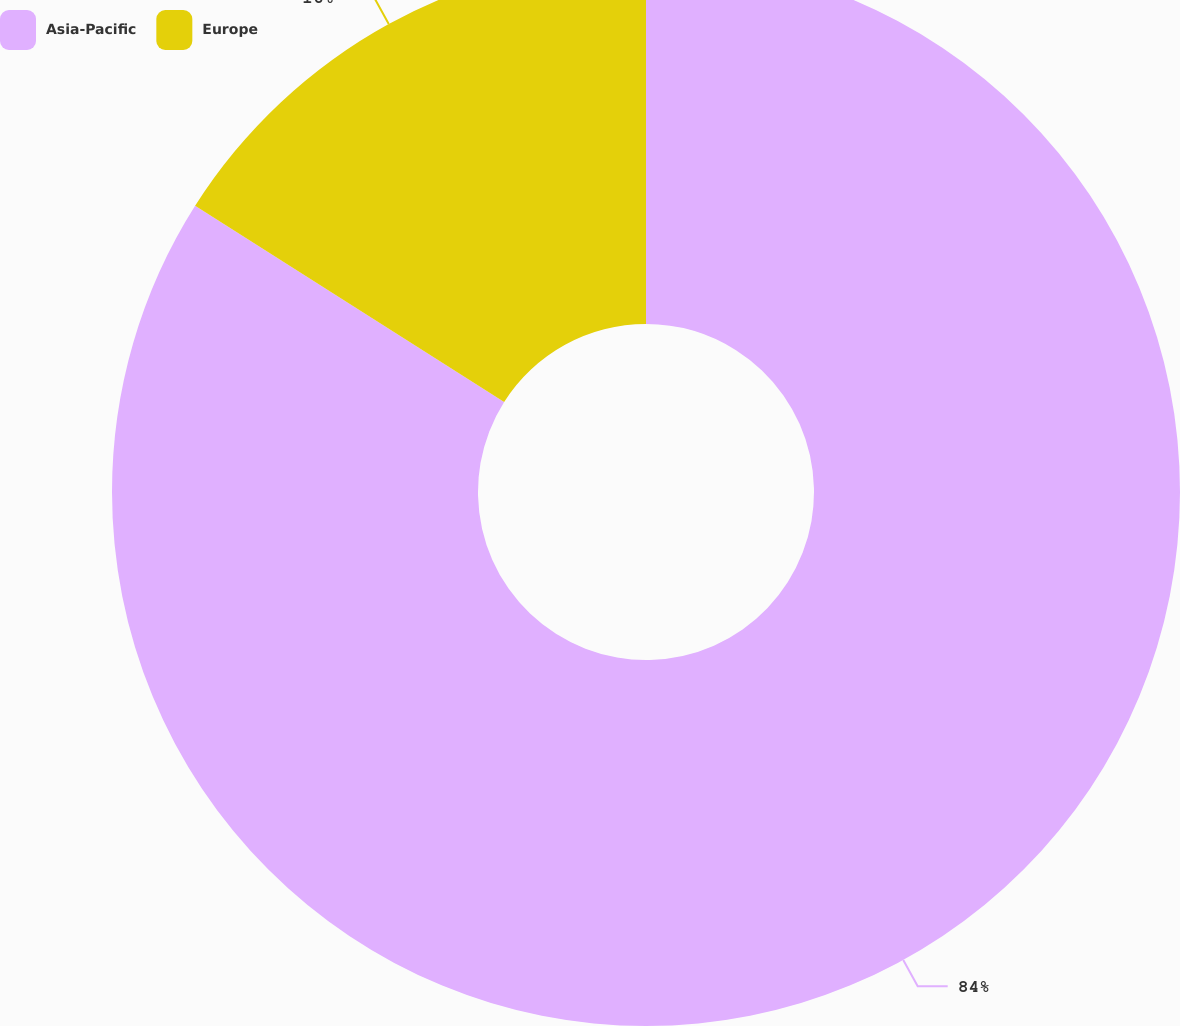Convert chart to OTSL. <chart><loc_0><loc_0><loc_500><loc_500><pie_chart><fcel>Asia-Pacific<fcel>Europe<nl><fcel>84.0%<fcel>16.0%<nl></chart> 